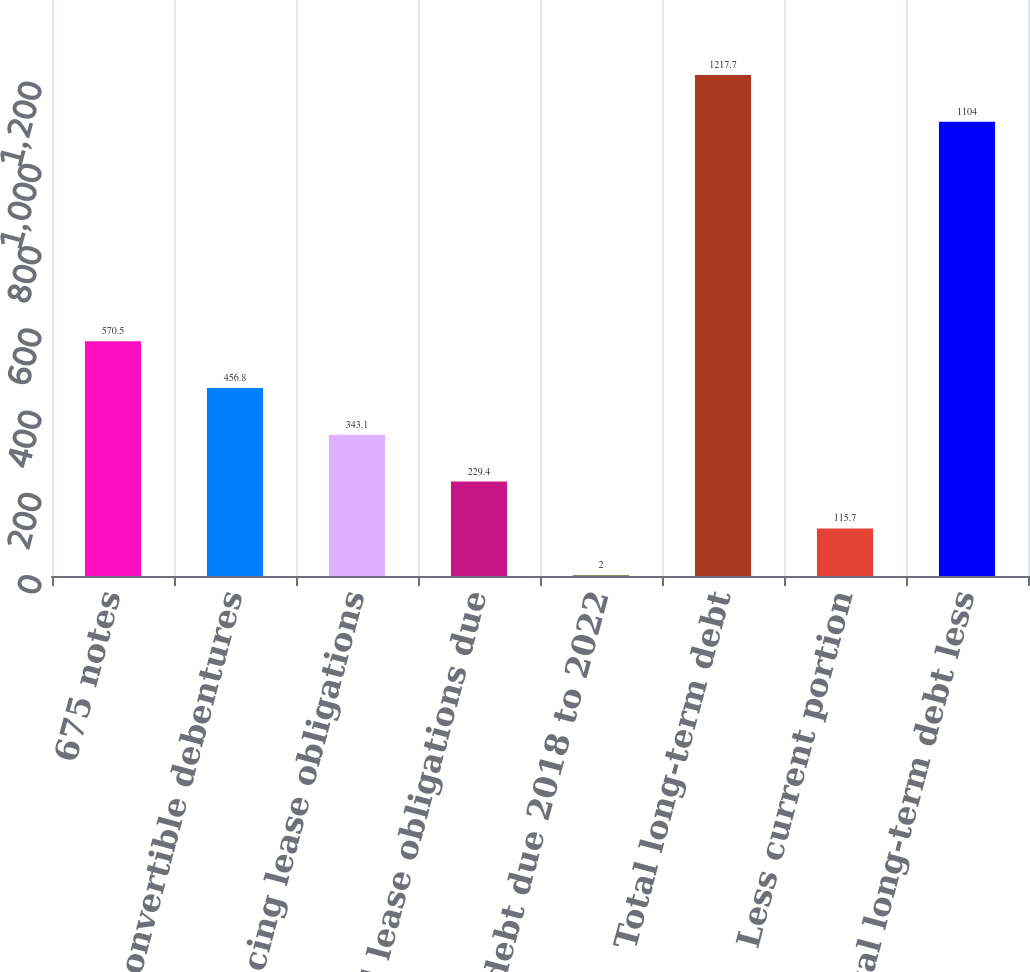Convert chart. <chart><loc_0><loc_0><loc_500><loc_500><bar_chart><fcel>675 notes<fcel>Convertible debentures<fcel>Financing lease obligations<fcel>Capital lease obligations due<fcel>Other debt due 2018 to 2022<fcel>Total long-term debt<fcel>Less current portion<fcel>Total long-term debt less<nl><fcel>570.5<fcel>456.8<fcel>343.1<fcel>229.4<fcel>2<fcel>1217.7<fcel>115.7<fcel>1104<nl></chart> 